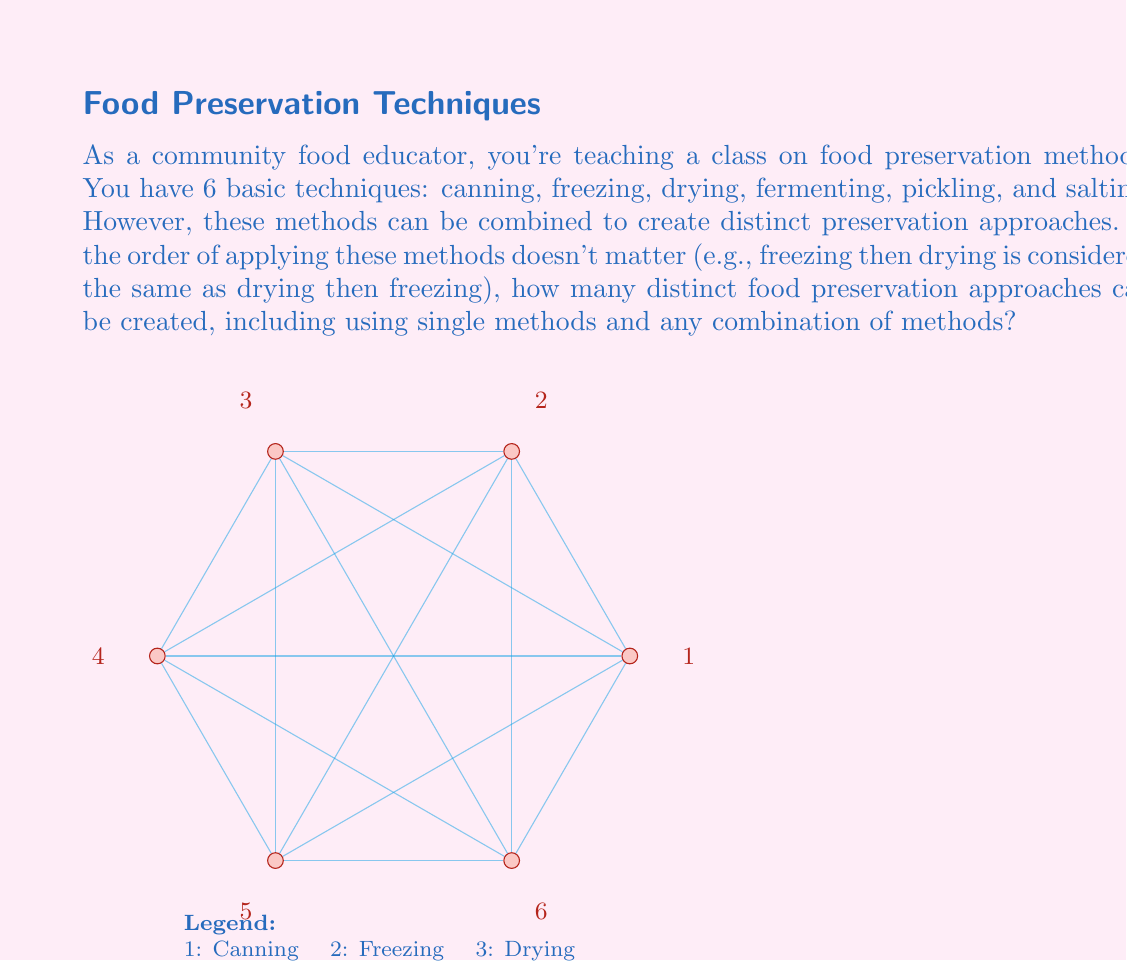Can you answer this question? To solve this problem, we can use the concept of group actions on sets. Here's a step-by-step approach:

1) First, we need to recognize that this problem is equivalent to finding the number of subsets of a set with 6 elements, where the order doesn't matter.

2) In group theory, this is related to the orbit-stabilizer theorem. The group acting on our set is the symmetric group $S_6$, and we're looking for the number of orbits under this action.

3) The number of orbits is given by Burnside's lemma:

   $$\text{Number of orbits} = \frac{1}{|G|} \sum_{g \in G} |X^g|$$

   where $G$ is our group ($S_6$), and $X^g$ is the set of elements fixed by $g$.

4) In our case, this simplifies to finding the number of subsets of a 6-element set, which is given by $2^6$.

5) This is because each element can either be in the subset or not, giving us 2 choices for each of the 6 elements.

6) Therefore, the number of distinct food preservation approaches is:

   $$2^6 = 64$$

This includes:
- 1 way to use no methods (leaving food as is)
- 6 ways to use a single method
- 15 ways to use two methods
- 20 ways to use three methods
- 15 ways to use four methods
- 6 ways to use five methods
- 1 way to use all six methods
Answer: 64 